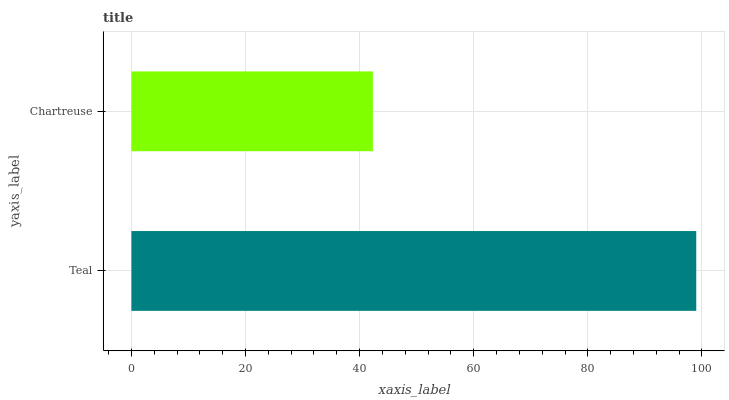Is Chartreuse the minimum?
Answer yes or no. Yes. Is Teal the maximum?
Answer yes or no. Yes. Is Chartreuse the maximum?
Answer yes or no. No. Is Teal greater than Chartreuse?
Answer yes or no. Yes. Is Chartreuse less than Teal?
Answer yes or no. Yes. Is Chartreuse greater than Teal?
Answer yes or no. No. Is Teal less than Chartreuse?
Answer yes or no. No. Is Teal the high median?
Answer yes or no. Yes. Is Chartreuse the low median?
Answer yes or no. Yes. Is Chartreuse the high median?
Answer yes or no. No. Is Teal the low median?
Answer yes or no. No. 